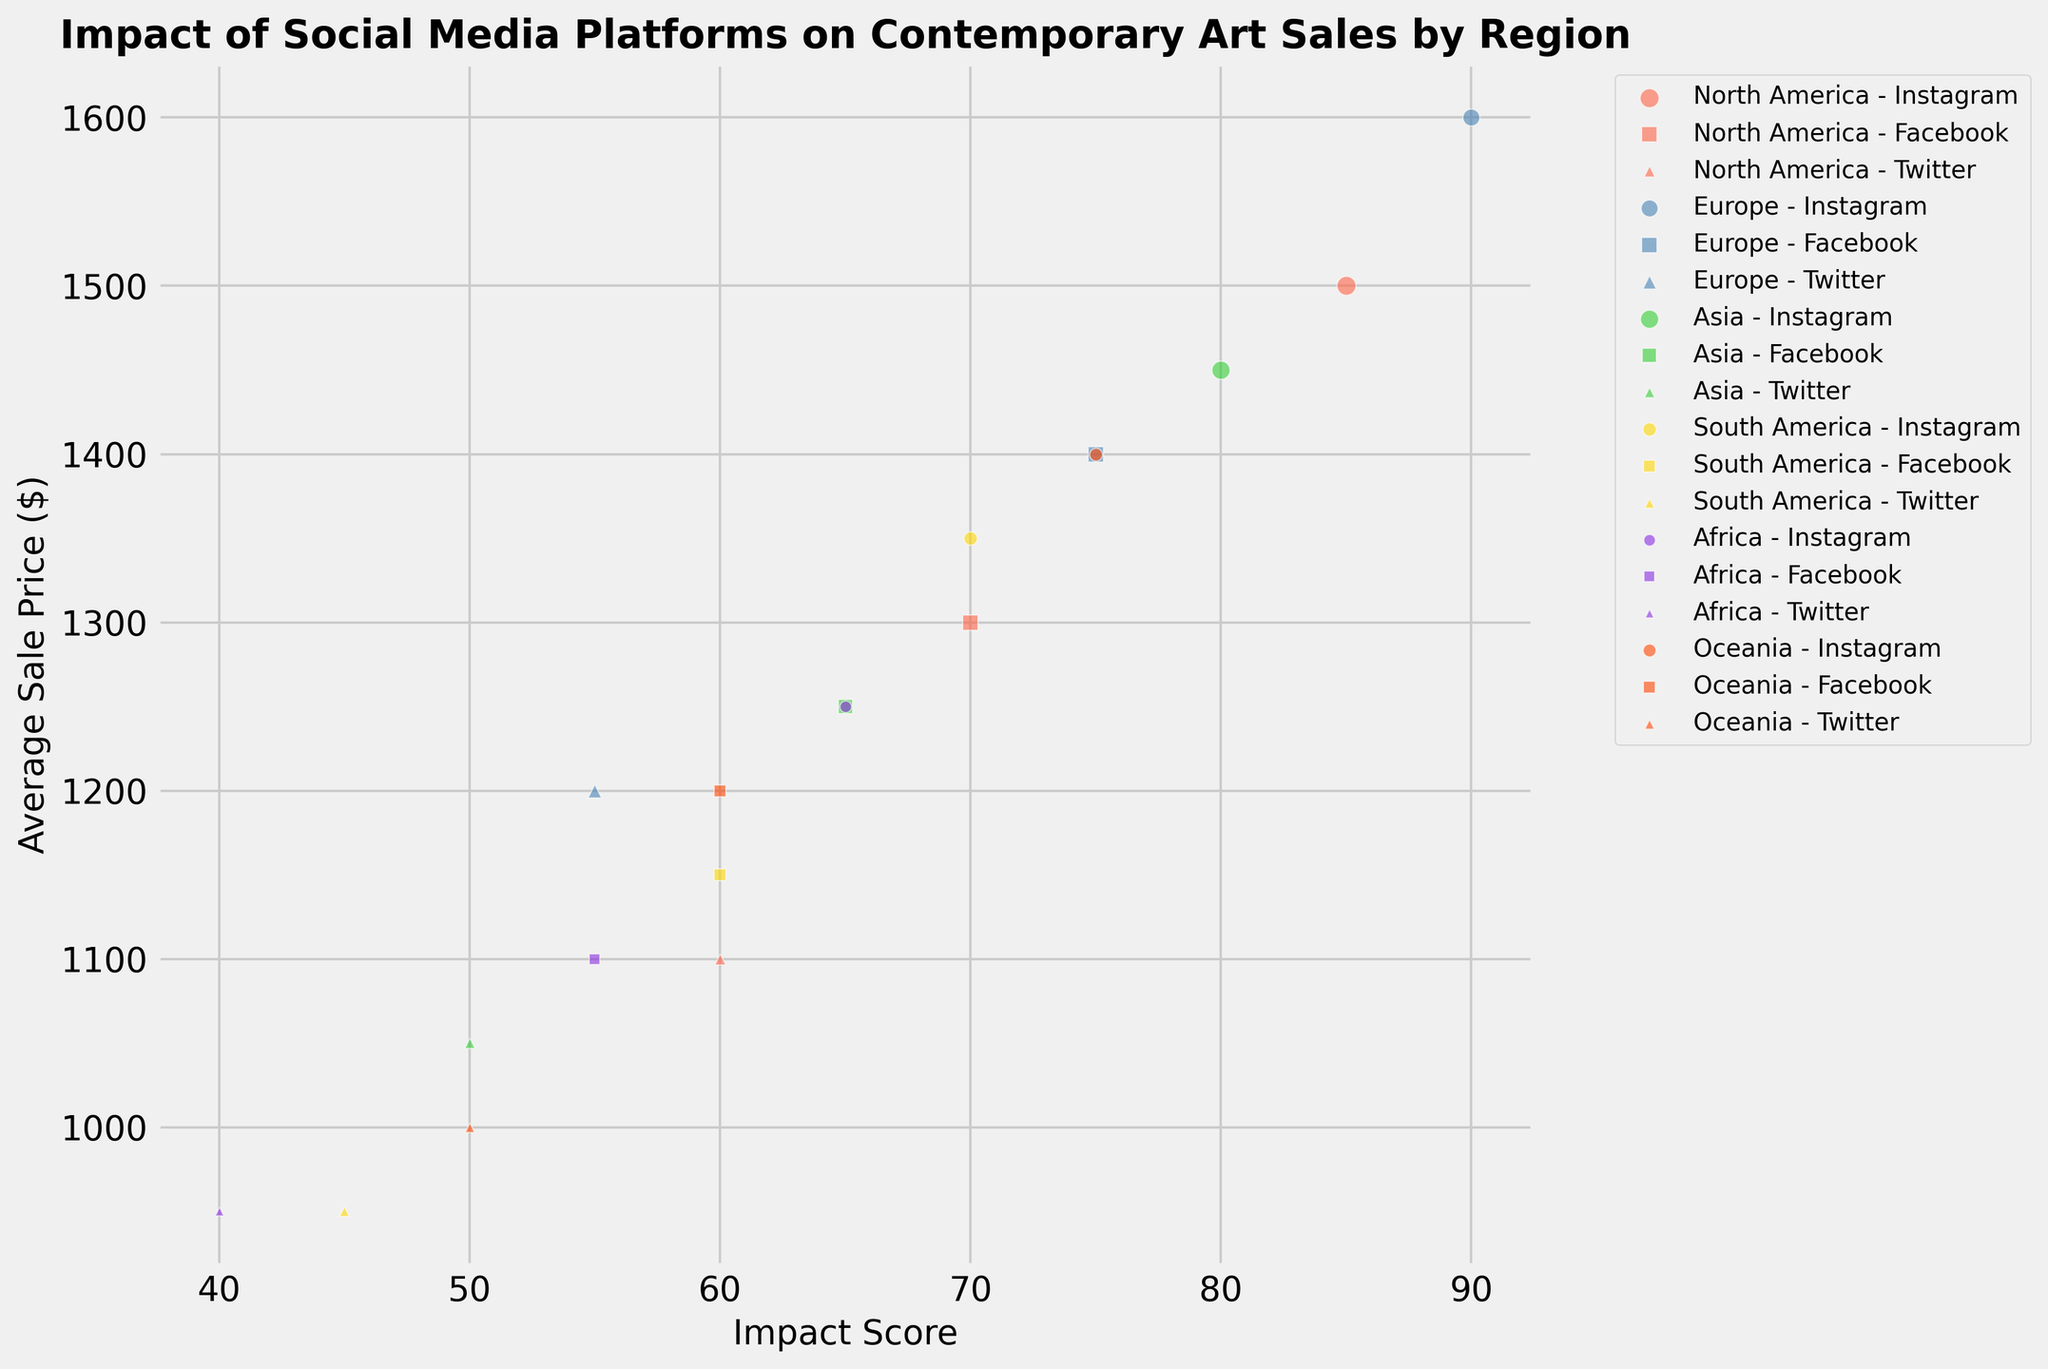Which region has the highest impact score for Instagram? By looking at the scatter plot and noting the color and marker for Instagram in different regions, we can see that Europe has the highest Instagram impact score, represented by the highest positioned blue circles on the x-axis.
Answer: Europe What is the difference in average sale price between Instagram and Twitter in North America? On the scatter plot, locate the North American markers for Instagram (orange circles) and Twitter (orange triangles). Instagram's average sale price is $1500, and Twitter's is $1100. The difference is $1500 - $1100.
Answer: $400 Which platform has the least impact on contemporary art sales in Africa, and what is its impact score? Identify the markers for Africa (purple) and compare the positions for Instagram, Facebook, and Twitter. The purple triangles (Twitter) have the lowest x-axis value, indicating the lowest impact score. This score is 40.
Answer: Twitter, 40 Compare the number of artists using Twitter in Asia with those using Facebook in Oceania. Which has more? Look at the size of the green triangles in Asia and the size of the red squares in Oceania. Asia's Twitter markers are larger, indicating more artists. Asia's Twitter has 350 artists, and Oceania's Facebook has 450 artists. Facebook in Oceania has more artists.
Answer: Facebook in Oceania What is the average impact score of Instagram across all regions? Sum the impact scores of Instagram for all regions and divide by the number of regions: (85+90+80+70+65+75) / 6. Calculate: (85+90+80+70+65+75) = 465, 465 / 6 = 77.5
Answer: 77.5 How does the average sale price of contemporary art on Facebook in Europe compare with Instagram in Asia? Locate the blue squares for Facebook in Europe and the green circles for Instagram in Asia. The average sale price for Facebook in Europe is $1400, and for Instagram in Asia, it is $1450. Instagram in Asia has a higher average sale price by $50.
Answer: $50 For South America, which platform has the most significant bubble, and what does it represent? In South America, the largest bubble (yellow circles) belongs to Instagram. This size corresponds to the number of artists, which is 600.
Answer: Instagram, Number of Artists: 600 What is the combined impact of Facebook and Twitter in Oceania compared to Instagram? Sum the impact scores of Facebook and Twitter in Oceania and compare them to Instagram. Facebook’s impact is 60, Twitter’s is 50, making (60 + 50) = 110. Instagram’s impact is 75. The combined impact of Facebook and Twitter (110) is greater than Instagram’s (75).
Answer: Combined: 110, Instagram: 75 